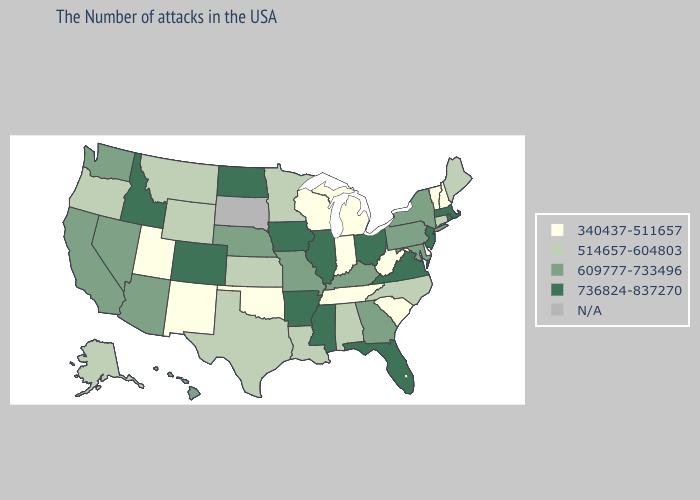What is the lowest value in the USA?
Quick response, please. 340437-511657. Name the states that have a value in the range 736824-837270?
Write a very short answer. Massachusetts, Rhode Island, New Jersey, Virginia, Ohio, Florida, Illinois, Mississippi, Arkansas, Iowa, North Dakota, Colorado, Idaho. Does Nebraska have the lowest value in the MidWest?
Concise answer only. No. Name the states that have a value in the range 340437-511657?
Write a very short answer. New Hampshire, Vermont, Delaware, South Carolina, West Virginia, Michigan, Indiana, Tennessee, Wisconsin, Oklahoma, New Mexico, Utah. What is the highest value in the USA?
Keep it brief. 736824-837270. Name the states that have a value in the range 609777-733496?
Concise answer only. New York, Maryland, Pennsylvania, Georgia, Kentucky, Missouri, Nebraska, Arizona, Nevada, California, Washington, Hawaii. What is the lowest value in the West?
Answer briefly. 340437-511657. Does Hawaii have the highest value in the West?
Answer briefly. No. Which states have the lowest value in the USA?
Short answer required. New Hampshire, Vermont, Delaware, South Carolina, West Virginia, Michigan, Indiana, Tennessee, Wisconsin, Oklahoma, New Mexico, Utah. Does the first symbol in the legend represent the smallest category?
Answer briefly. Yes. Which states have the highest value in the USA?
Short answer required. Massachusetts, Rhode Island, New Jersey, Virginia, Ohio, Florida, Illinois, Mississippi, Arkansas, Iowa, North Dakota, Colorado, Idaho. What is the lowest value in the USA?
Write a very short answer. 340437-511657. Does the first symbol in the legend represent the smallest category?
Give a very brief answer. Yes. What is the value of Iowa?
Give a very brief answer. 736824-837270. 